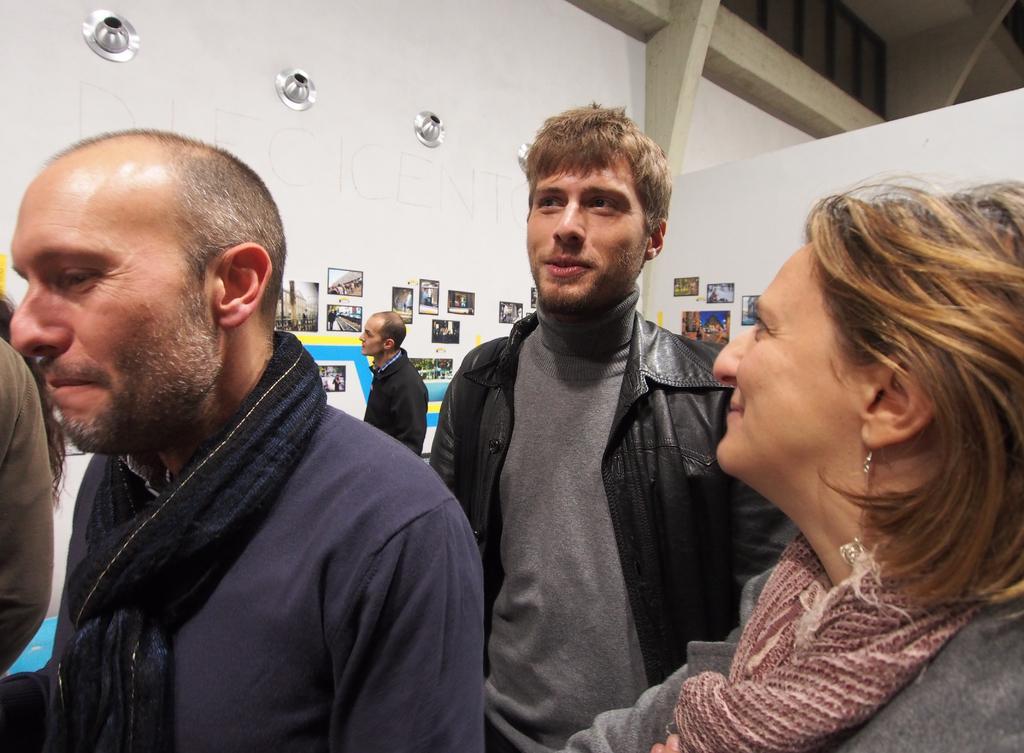How would you summarize this image in a sentence or two? In this picture I can see there are three people standing and they are wearing coats and there is a woman on top right side and the man on top left is smiling. There is a person standing in the backdrop and there are few photo frames on the wall. 